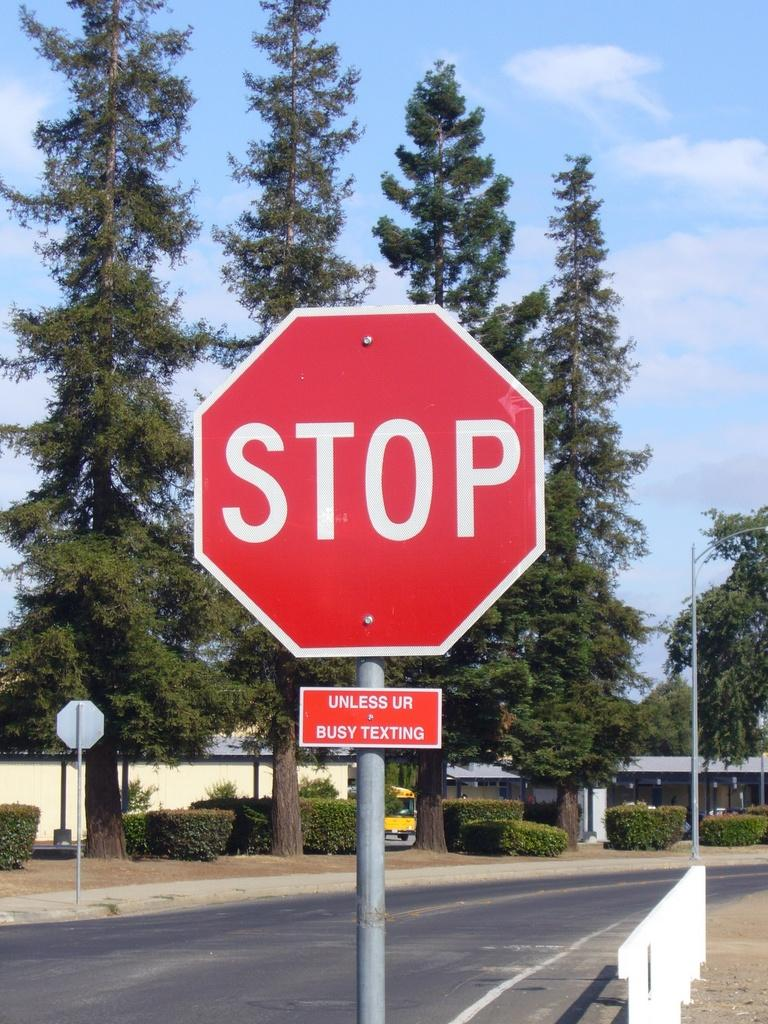<image>
Write a terse but informative summary of the picture. a stop sign that is near a group of trees 